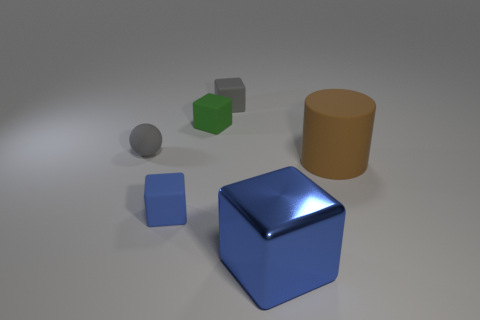There is a small rubber object that is behind the big matte cylinder and left of the tiny green object; what is its shape?
Make the answer very short. Sphere. Is the number of large cylinders that are on the left side of the brown thing the same as the number of large things?
Make the answer very short. No. What number of things are either small cubes that are behind the matte cylinder or rubber things?
Provide a succinct answer. 5. There is a matte block that is in front of the brown cylinder; does it have the same color as the large metallic cube?
Make the answer very short. Yes. There is a gray rubber object that is in front of the gray cube; how big is it?
Provide a succinct answer. Small. What shape is the gray rubber object that is on the left side of the blue cube that is on the left side of the blue metallic object?
Your answer should be compact. Sphere. What color is the metal thing that is the same shape as the blue rubber thing?
Your response must be concise. Blue. Does the blue matte thing on the left side of the green matte thing have the same size as the large blue object?
Offer a very short reply. No. The object that is the same color as the tiny sphere is what shape?
Your answer should be compact. Cube. How many gray balls have the same material as the brown cylinder?
Provide a succinct answer. 1. 